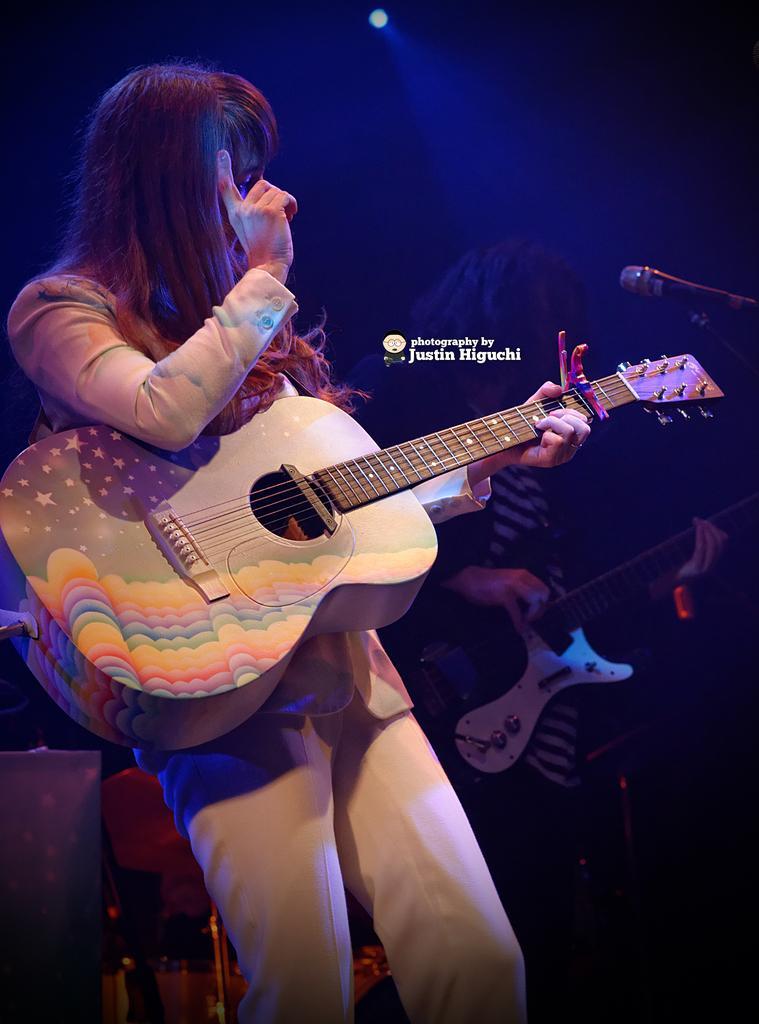Describe this image in one or two sentences. There is a woman standing here, with a guitar in her hand. In the background there is another one who is holding a guitar in front of a microphone. There is a light in the background. 